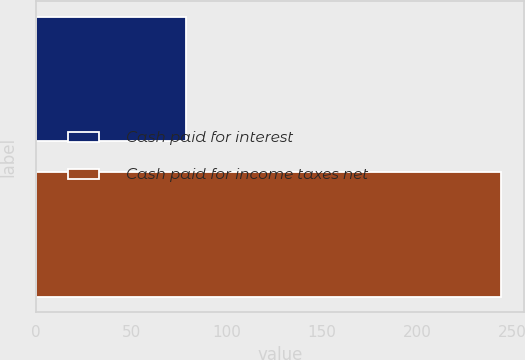<chart> <loc_0><loc_0><loc_500><loc_500><bar_chart><fcel>Cash paid for interest<fcel>Cash paid for income taxes net<nl><fcel>78.8<fcel>244.1<nl></chart> 